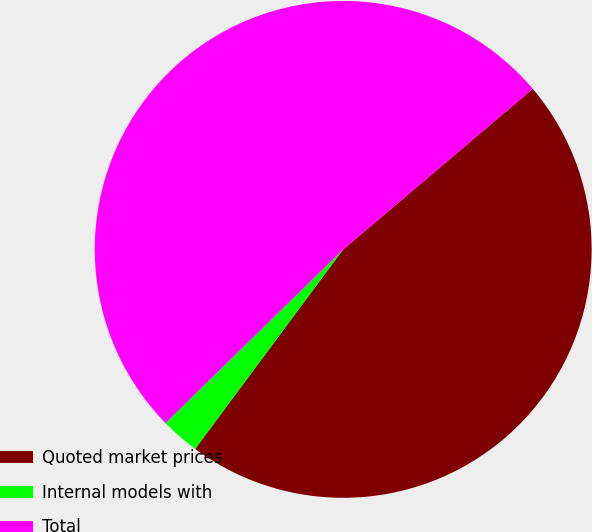Convert chart. <chart><loc_0><loc_0><loc_500><loc_500><pie_chart><fcel>Quoted market prices<fcel>Internal models with<fcel>Total<nl><fcel>46.35%<fcel>2.52%<fcel>51.13%<nl></chart> 